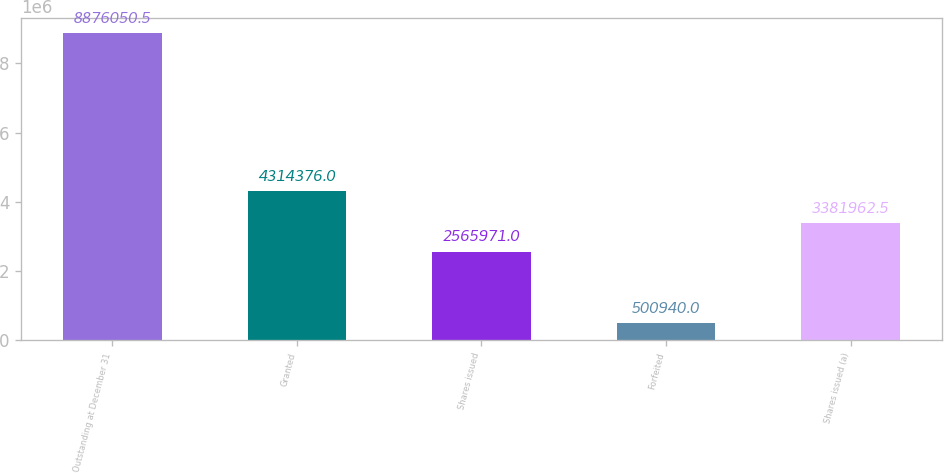<chart> <loc_0><loc_0><loc_500><loc_500><bar_chart><fcel>Outstanding at December 31<fcel>Granted<fcel>Shares issued<fcel>Forfeited<fcel>Shares issued (a)<nl><fcel>8.87605e+06<fcel>4.31438e+06<fcel>2.56597e+06<fcel>500940<fcel>3.38196e+06<nl></chart> 